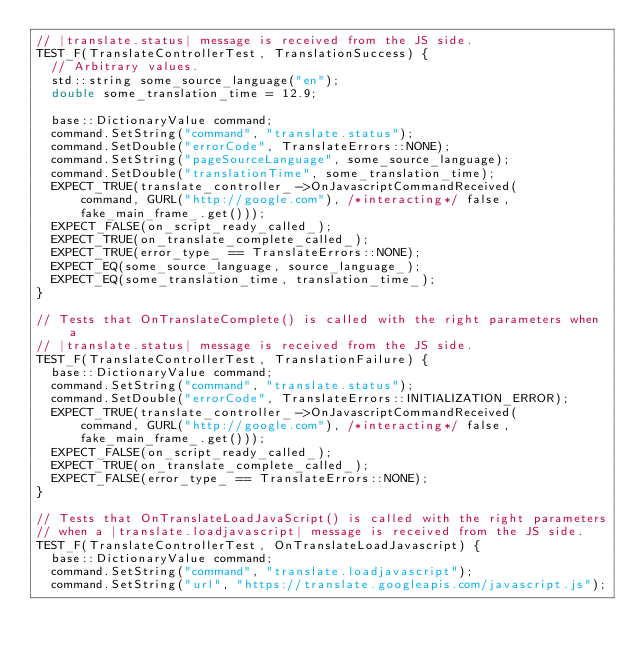Convert code to text. <code><loc_0><loc_0><loc_500><loc_500><_ObjectiveC_>// |translate.status| message is received from the JS side.
TEST_F(TranslateControllerTest, TranslationSuccess) {
  // Arbitrary values.
  std::string some_source_language("en");
  double some_translation_time = 12.9;

  base::DictionaryValue command;
  command.SetString("command", "translate.status");
  command.SetDouble("errorCode", TranslateErrors::NONE);
  command.SetString("pageSourceLanguage", some_source_language);
  command.SetDouble("translationTime", some_translation_time);
  EXPECT_TRUE(translate_controller_->OnJavascriptCommandReceived(
      command, GURL("http://google.com"), /*interacting*/ false,
      fake_main_frame_.get()));
  EXPECT_FALSE(on_script_ready_called_);
  EXPECT_TRUE(on_translate_complete_called_);
  EXPECT_TRUE(error_type_ == TranslateErrors::NONE);
  EXPECT_EQ(some_source_language, source_language_);
  EXPECT_EQ(some_translation_time, translation_time_);
}

// Tests that OnTranslateComplete() is called with the right parameters when a
// |translate.status| message is received from the JS side.
TEST_F(TranslateControllerTest, TranslationFailure) {
  base::DictionaryValue command;
  command.SetString("command", "translate.status");
  command.SetDouble("errorCode", TranslateErrors::INITIALIZATION_ERROR);
  EXPECT_TRUE(translate_controller_->OnJavascriptCommandReceived(
      command, GURL("http://google.com"), /*interacting*/ false,
      fake_main_frame_.get()));
  EXPECT_FALSE(on_script_ready_called_);
  EXPECT_TRUE(on_translate_complete_called_);
  EXPECT_FALSE(error_type_ == TranslateErrors::NONE);
}

// Tests that OnTranslateLoadJavaScript() is called with the right parameters
// when a |translate.loadjavascript| message is received from the JS side.
TEST_F(TranslateControllerTest, OnTranslateLoadJavascript) {
  base::DictionaryValue command;
  command.SetString("command", "translate.loadjavascript");
  command.SetString("url", "https://translate.googleapis.com/javascript.js");</code> 